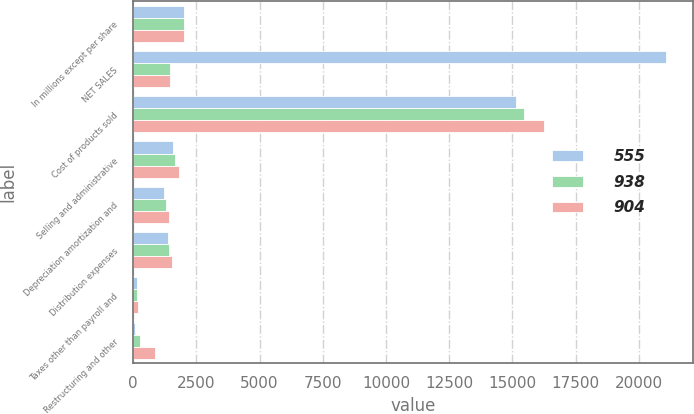Convert chart to OTSL. <chart><loc_0><loc_0><loc_500><loc_500><stacked_bar_chart><ecel><fcel>In millions except per share<fcel>NET SALES<fcel>Cost of products sold<fcel>Selling and administrative<fcel>Depreciation amortization and<fcel>Distribution expenses<fcel>Taxes other than payroll and<fcel>Restructuring and other<nl><fcel>555<fcel>2016<fcel>21079<fcel>15152<fcel>1575<fcel>1227<fcel>1361<fcel>164<fcel>54<nl><fcel>938<fcel>2015<fcel>1463.5<fcel>15468<fcel>1645<fcel>1294<fcel>1406<fcel>168<fcel>252<nl><fcel>904<fcel>2014<fcel>1463.5<fcel>16254<fcel>1793<fcel>1406<fcel>1521<fcel>180<fcel>846<nl></chart> 